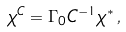<formula> <loc_0><loc_0><loc_500><loc_500>\chi ^ { C } = \Gamma _ { 0 } C ^ { - 1 } \chi ^ { \ast } \, ,</formula> 